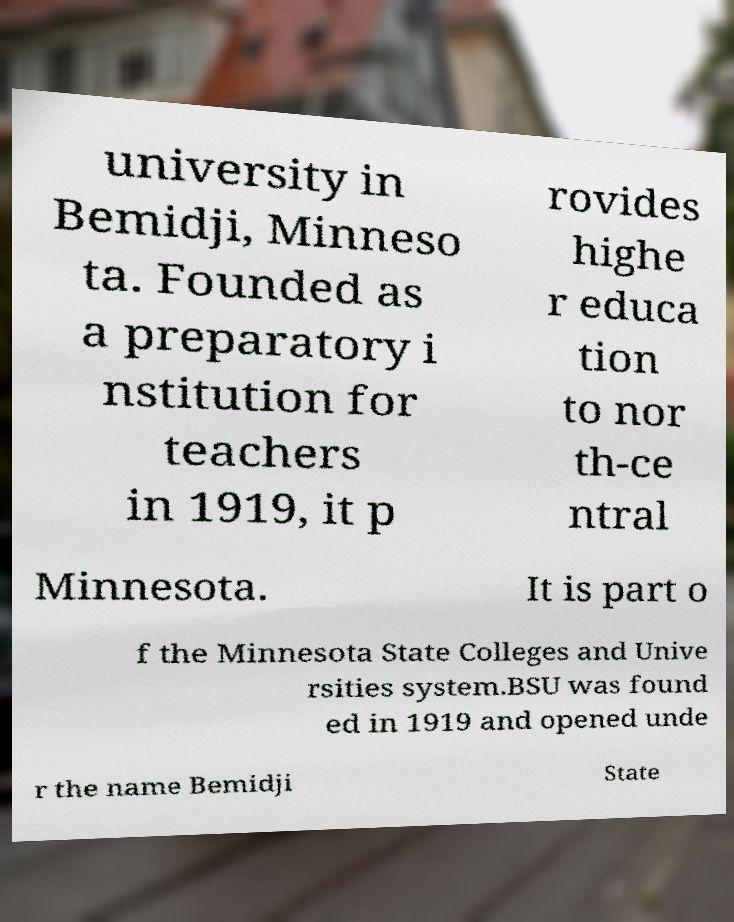Can you read and provide the text displayed in the image?This photo seems to have some interesting text. Can you extract and type it out for me? university in Bemidji, Minneso ta. Founded as a preparatory i nstitution for teachers in 1919, it p rovides highe r educa tion to nor th-ce ntral Minnesota. It is part o f the Minnesota State Colleges and Unive rsities system.BSU was found ed in 1919 and opened unde r the name Bemidji State 